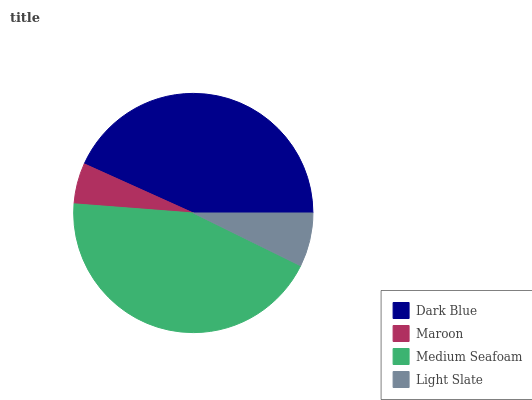Is Maroon the minimum?
Answer yes or no. Yes. Is Medium Seafoam the maximum?
Answer yes or no. Yes. Is Medium Seafoam the minimum?
Answer yes or no. No. Is Maroon the maximum?
Answer yes or no. No. Is Medium Seafoam greater than Maroon?
Answer yes or no. Yes. Is Maroon less than Medium Seafoam?
Answer yes or no. Yes. Is Maroon greater than Medium Seafoam?
Answer yes or no. No. Is Medium Seafoam less than Maroon?
Answer yes or no. No. Is Dark Blue the high median?
Answer yes or no. Yes. Is Light Slate the low median?
Answer yes or no. Yes. Is Medium Seafoam the high median?
Answer yes or no. No. Is Maroon the low median?
Answer yes or no. No. 